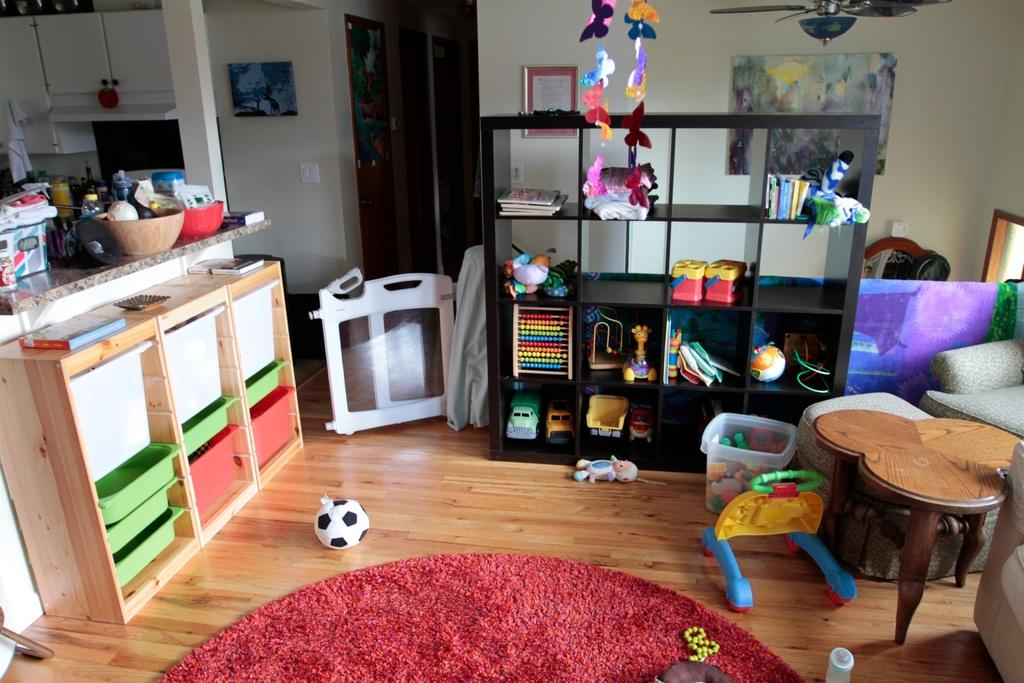What type of location is depicted in the image? The image shows an inner view of a house. What can be seen on a shelf in the image? There are toys on a shelf in the image. What piece of furniture is present in the image? There is a table in the image. What object is visible on the floor in the image? There is a ball in the image. What area of the house is visible in the image? The counter top of a kitchen is visible in the image. What type of bubble can be seen floating in the image? There is no bubble present in the image. What song is being played in the background of the image? There is no indication of any music or song in the image. 